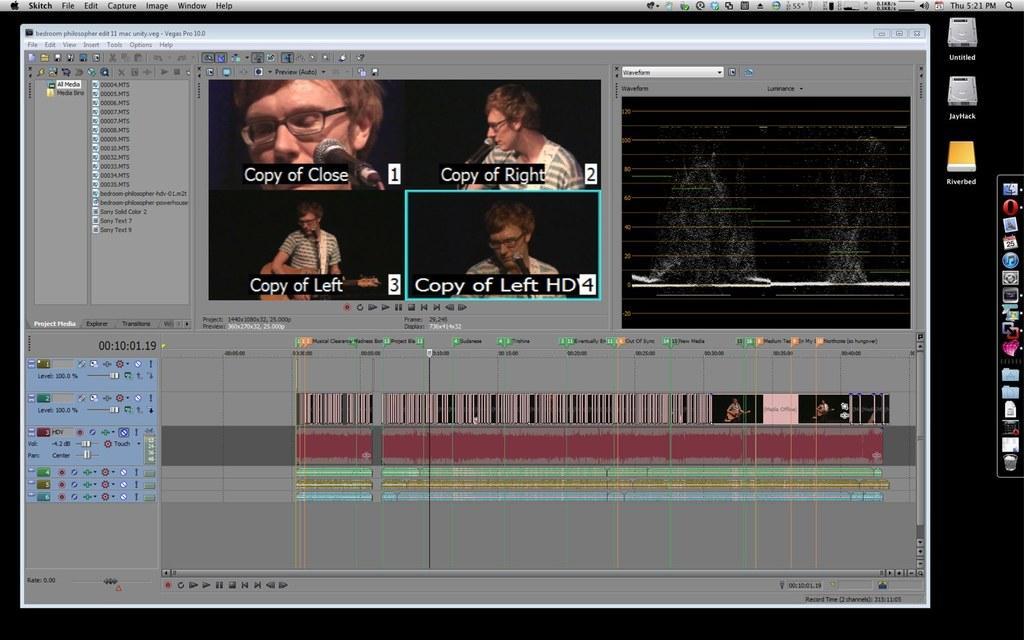Could you give a brief overview of what you see in this image? This is a screenshot of a monitor. In this picture there are icons and there is a dialogue box, in the dialogue box there are text, person, mic and other things. 